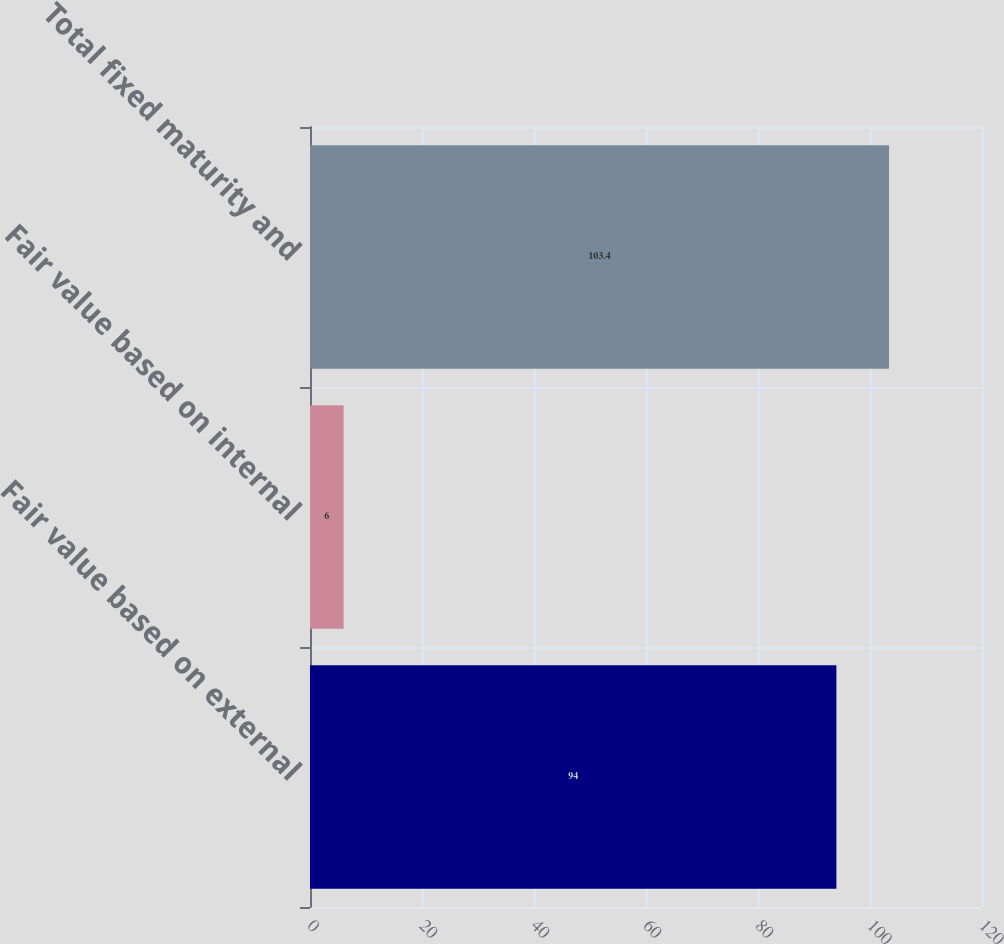<chart> <loc_0><loc_0><loc_500><loc_500><bar_chart><fcel>Fair value based on external<fcel>Fair value based on internal<fcel>Total fixed maturity and<nl><fcel>94<fcel>6<fcel>103.4<nl></chart> 